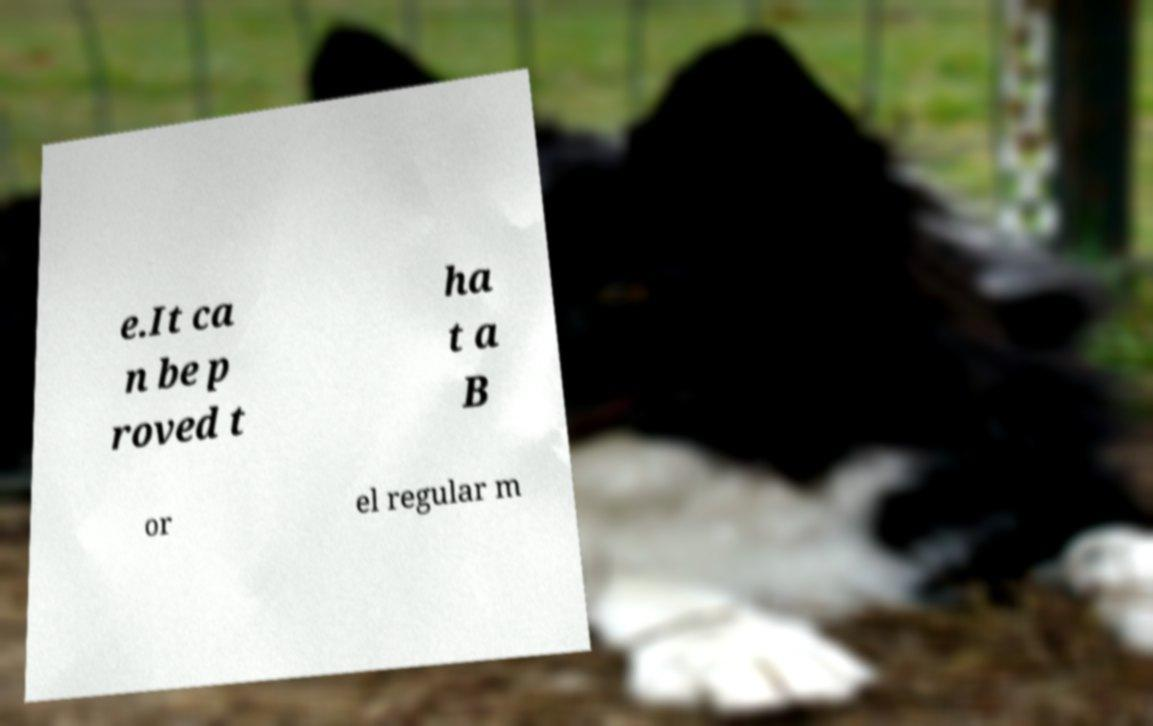Could you extract and type out the text from this image? e.It ca n be p roved t ha t a B or el regular m 